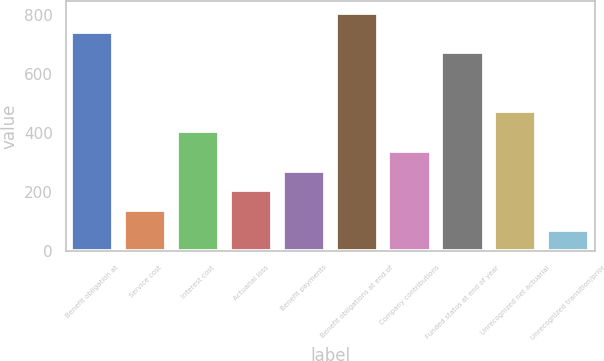Convert chart to OTSL. <chart><loc_0><loc_0><loc_500><loc_500><bar_chart><fcel>Benefit obligation at<fcel>Service cost<fcel>Interest cost<fcel>Actuarial loss<fcel>Benefit payments<fcel>Benefit obligations at end of<fcel>Company contributions<fcel>Funded status at end of year<fcel>Unrecognized net actuarial<fcel>Unrecognized transition/prior<nl><fcel>742.86<fcel>139.59<fcel>407.71<fcel>206.62<fcel>273.65<fcel>809.89<fcel>340.68<fcel>675.83<fcel>474.74<fcel>72.56<nl></chart> 